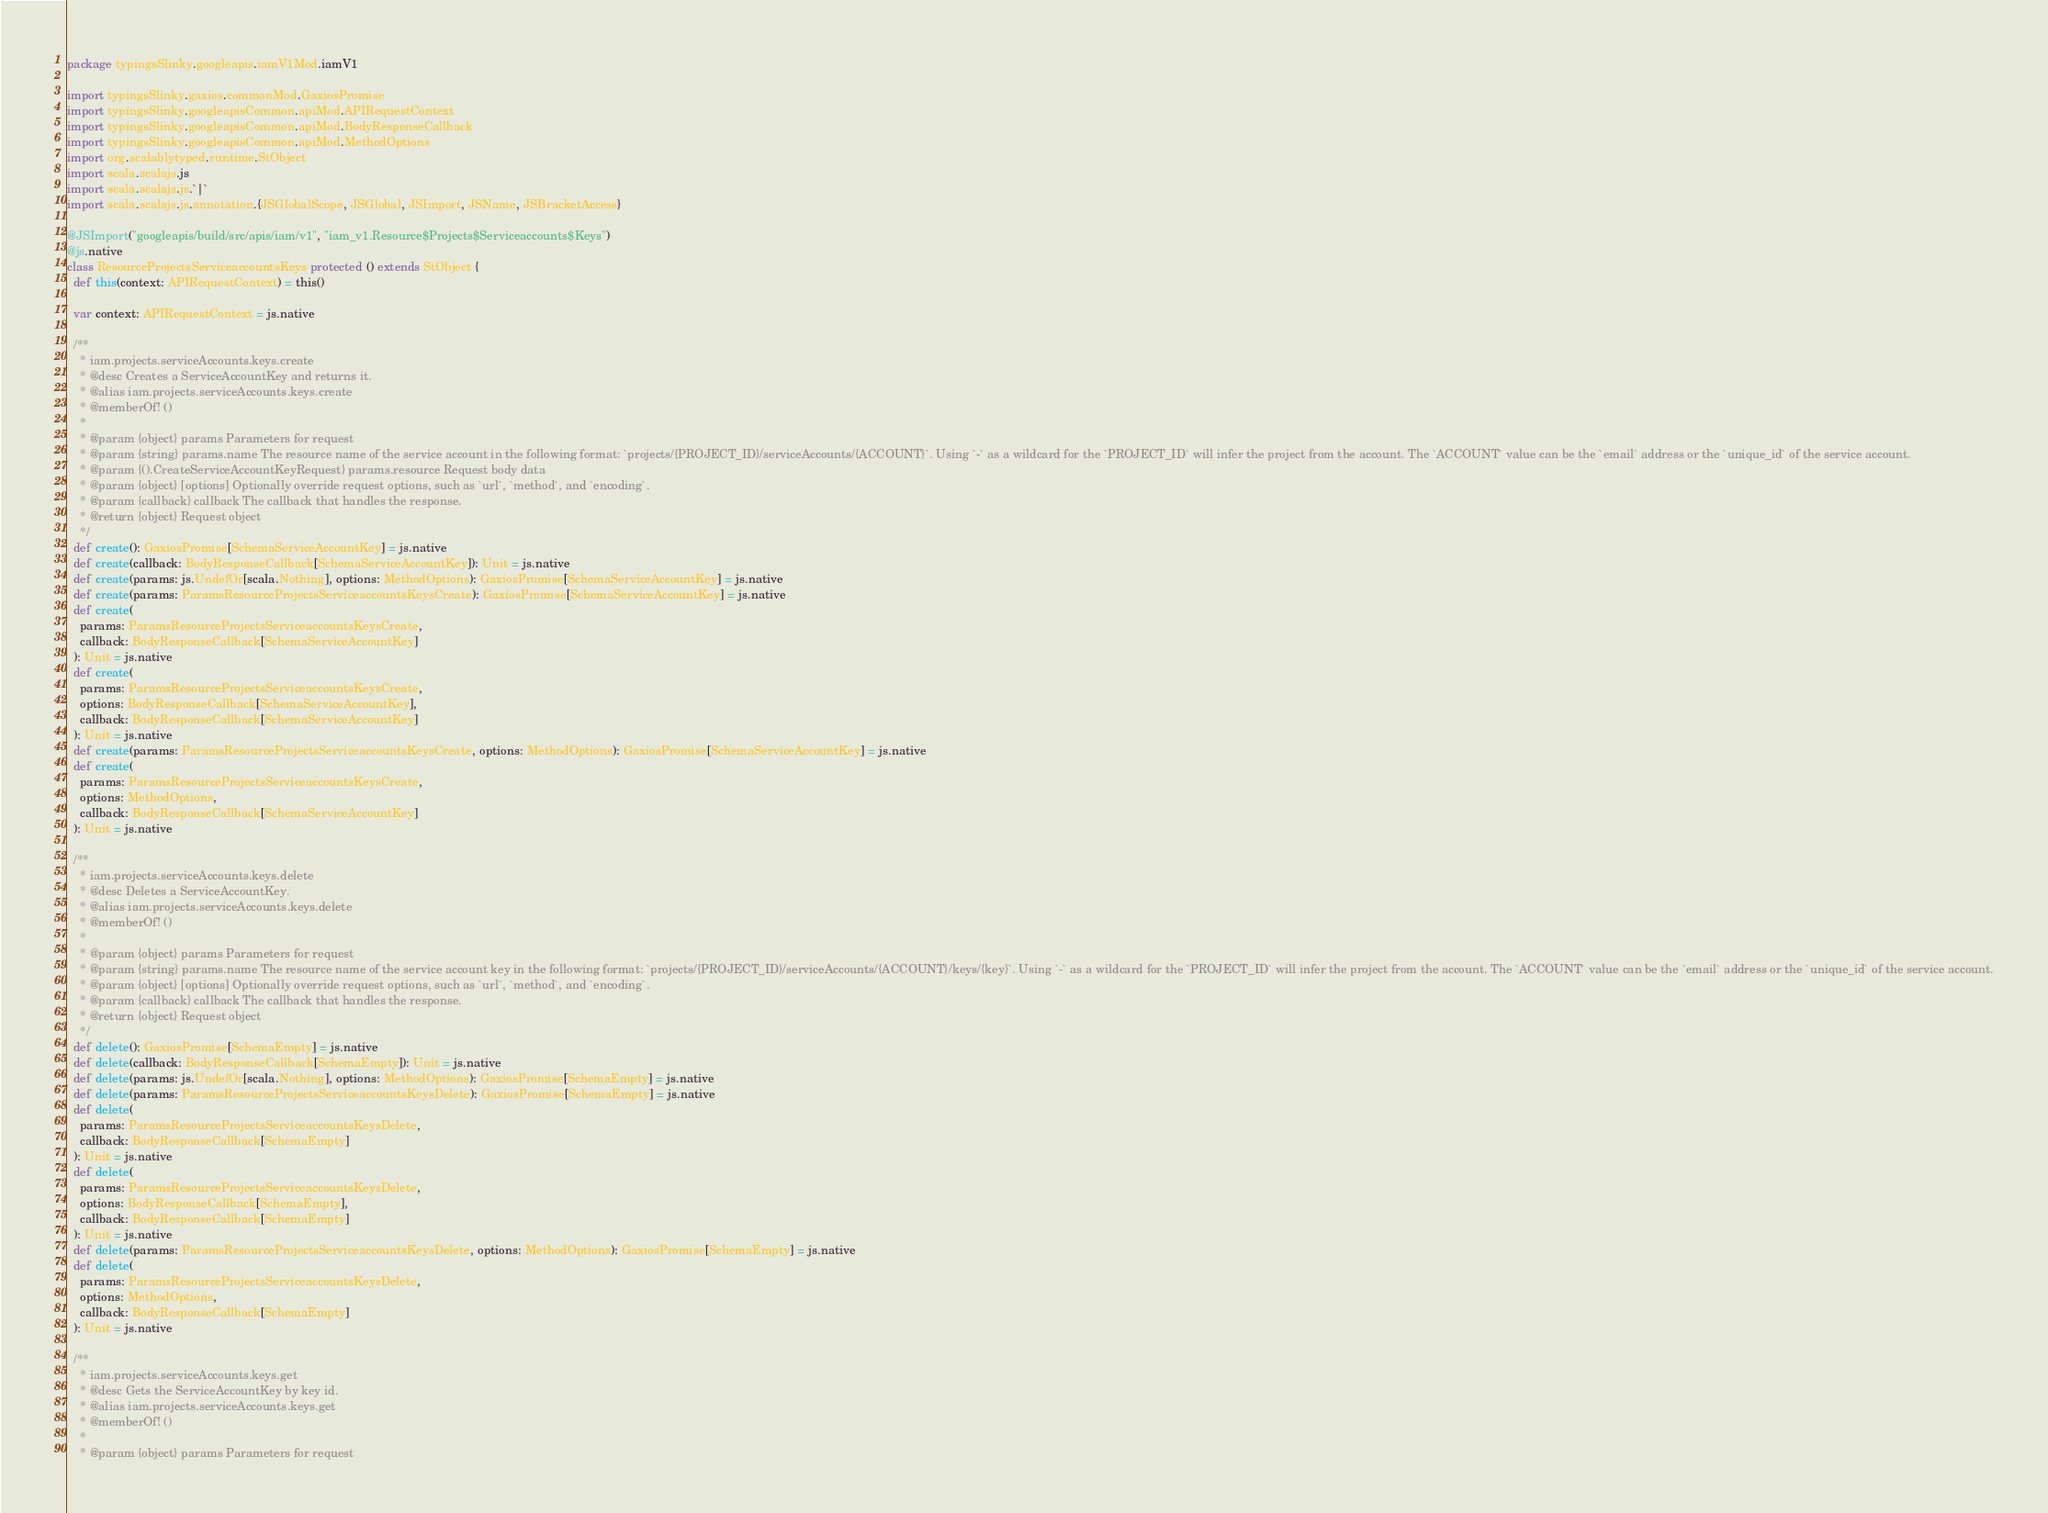<code> <loc_0><loc_0><loc_500><loc_500><_Scala_>package typingsSlinky.googleapis.iamV1Mod.iamV1

import typingsSlinky.gaxios.commonMod.GaxiosPromise
import typingsSlinky.googleapisCommon.apiMod.APIRequestContext
import typingsSlinky.googleapisCommon.apiMod.BodyResponseCallback
import typingsSlinky.googleapisCommon.apiMod.MethodOptions
import org.scalablytyped.runtime.StObject
import scala.scalajs.js
import scala.scalajs.js.`|`
import scala.scalajs.js.annotation.{JSGlobalScope, JSGlobal, JSImport, JSName, JSBracketAccess}

@JSImport("googleapis/build/src/apis/iam/v1", "iam_v1.Resource$Projects$Serviceaccounts$Keys")
@js.native
class ResourceProjectsServiceaccountsKeys protected () extends StObject {
  def this(context: APIRequestContext) = this()
  
  var context: APIRequestContext = js.native
  
  /**
    * iam.projects.serviceAccounts.keys.create
    * @desc Creates a ServiceAccountKey and returns it.
    * @alias iam.projects.serviceAccounts.keys.create
    * @memberOf! ()
    *
    * @param {object} params Parameters for request
    * @param {string} params.name The resource name of the service account in the following format: `projects/{PROJECT_ID}/serviceAccounts/{ACCOUNT}`. Using `-` as a wildcard for the `PROJECT_ID` will infer the project from the account. The `ACCOUNT` value can be the `email` address or the `unique_id` of the service account.
    * @param {().CreateServiceAccountKeyRequest} params.resource Request body data
    * @param {object} [options] Optionally override request options, such as `url`, `method`, and `encoding`.
    * @param {callback} callback The callback that handles the response.
    * @return {object} Request object
    */
  def create(): GaxiosPromise[SchemaServiceAccountKey] = js.native
  def create(callback: BodyResponseCallback[SchemaServiceAccountKey]): Unit = js.native
  def create(params: js.UndefOr[scala.Nothing], options: MethodOptions): GaxiosPromise[SchemaServiceAccountKey] = js.native
  def create(params: ParamsResourceProjectsServiceaccountsKeysCreate): GaxiosPromise[SchemaServiceAccountKey] = js.native
  def create(
    params: ParamsResourceProjectsServiceaccountsKeysCreate,
    callback: BodyResponseCallback[SchemaServiceAccountKey]
  ): Unit = js.native
  def create(
    params: ParamsResourceProjectsServiceaccountsKeysCreate,
    options: BodyResponseCallback[SchemaServiceAccountKey],
    callback: BodyResponseCallback[SchemaServiceAccountKey]
  ): Unit = js.native
  def create(params: ParamsResourceProjectsServiceaccountsKeysCreate, options: MethodOptions): GaxiosPromise[SchemaServiceAccountKey] = js.native
  def create(
    params: ParamsResourceProjectsServiceaccountsKeysCreate,
    options: MethodOptions,
    callback: BodyResponseCallback[SchemaServiceAccountKey]
  ): Unit = js.native
  
  /**
    * iam.projects.serviceAccounts.keys.delete
    * @desc Deletes a ServiceAccountKey.
    * @alias iam.projects.serviceAccounts.keys.delete
    * @memberOf! ()
    *
    * @param {object} params Parameters for request
    * @param {string} params.name The resource name of the service account key in the following format: `projects/{PROJECT_ID}/serviceAccounts/{ACCOUNT}/keys/{key}`. Using `-` as a wildcard for the `PROJECT_ID` will infer the project from the account. The `ACCOUNT` value can be the `email` address or the `unique_id` of the service account.
    * @param {object} [options] Optionally override request options, such as `url`, `method`, and `encoding`.
    * @param {callback} callback The callback that handles the response.
    * @return {object} Request object
    */
  def delete(): GaxiosPromise[SchemaEmpty] = js.native
  def delete(callback: BodyResponseCallback[SchemaEmpty]): Unit = js.native
  def delete(params: js.UndefOr[scala.Nothing], options: MethodOptions): GaxiosPromise[SchemaEmpty] = js.native
  def delete(params: ParamsResourceProjectsServiceaccountsKeysDelete): GaxiosPromise[SchemaEmpty] = js.native
  def delete(
    params: ParamsResourceProjectsServiceaccountsKeysDelete,
    callback: BodyResponseCallback[SchemaEmpty]
  ): Unit = js.native
  def delete(
    params: ParamsResourceProjectsServiceaccountsKeysDelete,
    options: BodyResponseCallback[SchemaEmpty],
    callback: BodyResponseCallback[SchemaEmpty]
  ): Unit = js.native
  def delete(params: ParamsResourceProjectsServiceaccountsKeysDelete, options: MethodOptions): GaxiosPromise[SchemaEmpty] = js.native
  def delete(
    params: ParamsResourceProjectsServiceaccountsKeysDelete,
    options: MethodOptions,
    callback: BodyResponseCallback[SchemaEmpty]
  ): Unit = js.native
  
  /**
    * iam.projects.serviceAccounts.keys.get
    * @desc Gets the ServiceAccountKey by key id.
    * @alias iam.projects.serviceAccounts.keys.get
    * @memberOf! ()
    *
    * @param {object} params Parameters for request</code> 